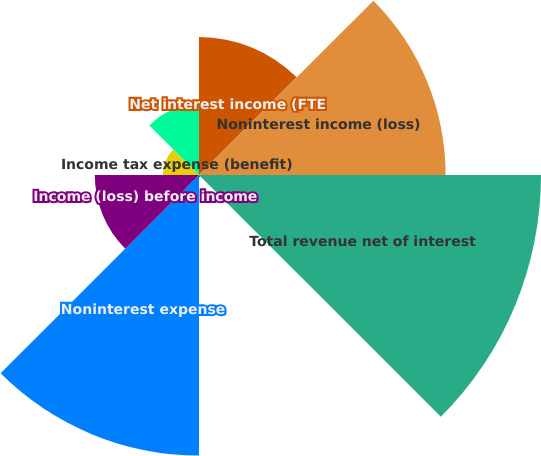<chart> <loc_0><loc_0><loc_500><loc_500><pie_chart><fcel>Net interest income (FTE<fcel>Noninterest income (loss)<fcel>Total revenue net of interest<fcel>Provision for credit losses<fcel>Noninterest expense<fcel>Income (loss) before income<fcel>Income tax expense (benefit)<fcel>Net income (loss)<nl><fcel>11.32%<fcel>20.21%<fcel>28.03%<fcel>0.18%<fcel>22.99%<fcel>8.54%<fcel>2.97%<fcel>5.75%<nl></chart> 